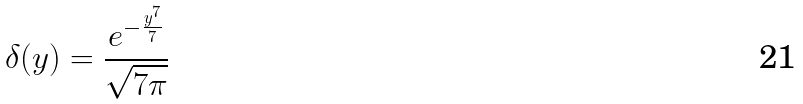Convert formula to latex. <formula><loc_0><loc_0><loc_500><loc_500>\delta ( y ) = \frac { e ^ { - \frac { y ^ { 7 } } { 7 } } } { \sqrt { 7 \pi } }</formula> 